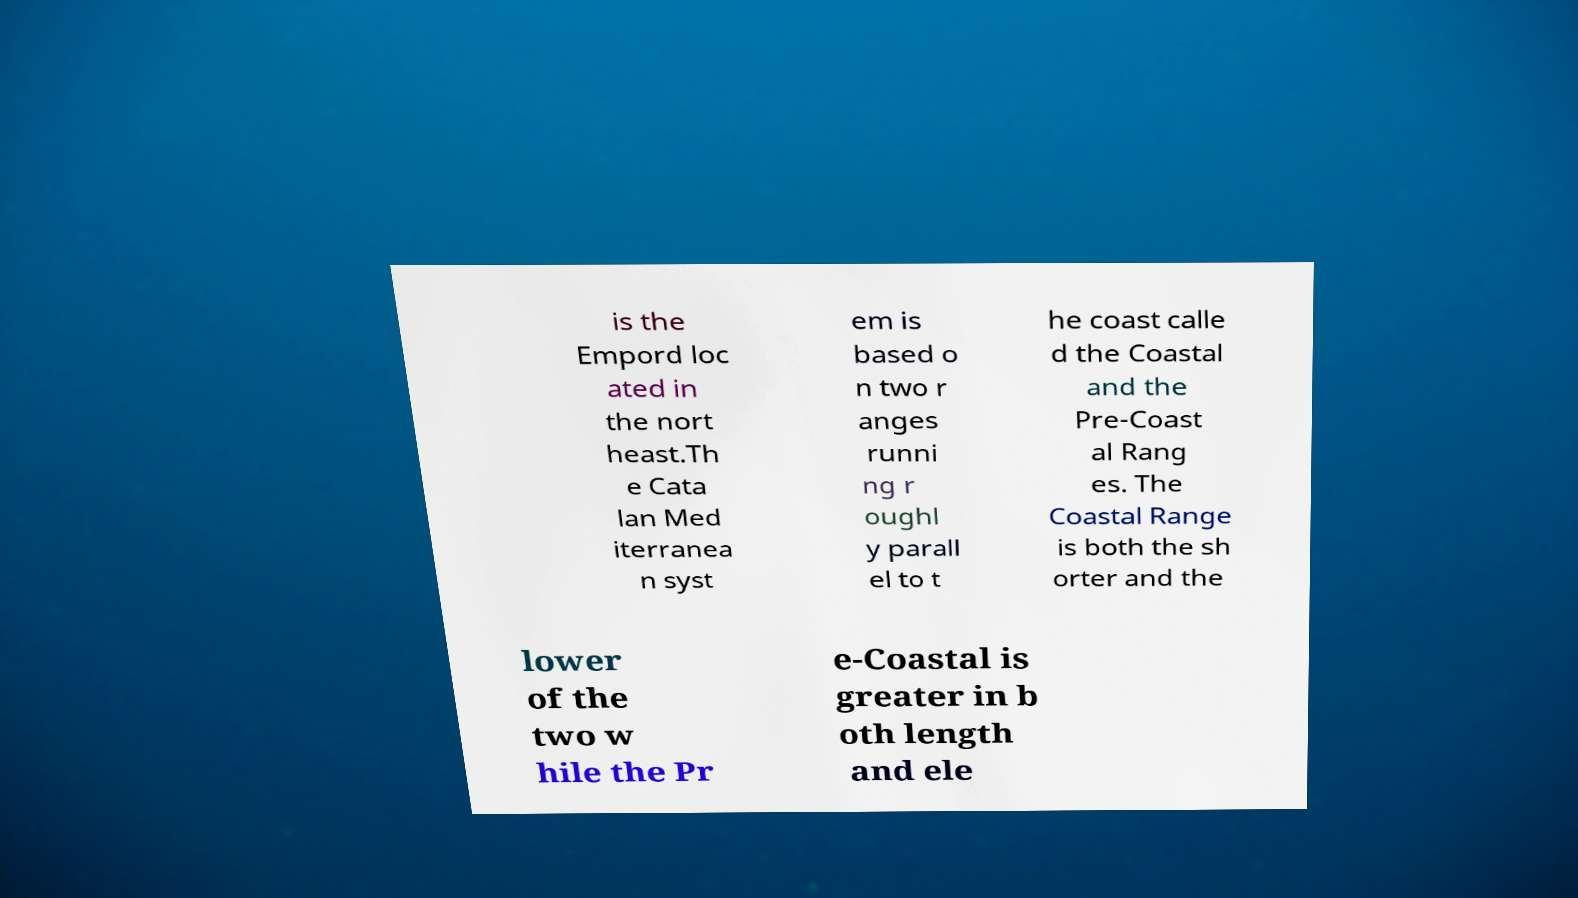I need the written content from this picture converted into text. Can you do that? is the Empord loc ated in the nort heast.Th e Cata lan Med iterranea n syst em is based o n two r anges runni ng r oughl y parall el to t he coast calle d the Coastal and the Pre-Coast al Rang es. The Coastal Range is both the sh orter and the lower of the two w hile the Pr e-Coastal is greater in b oth length and ele 